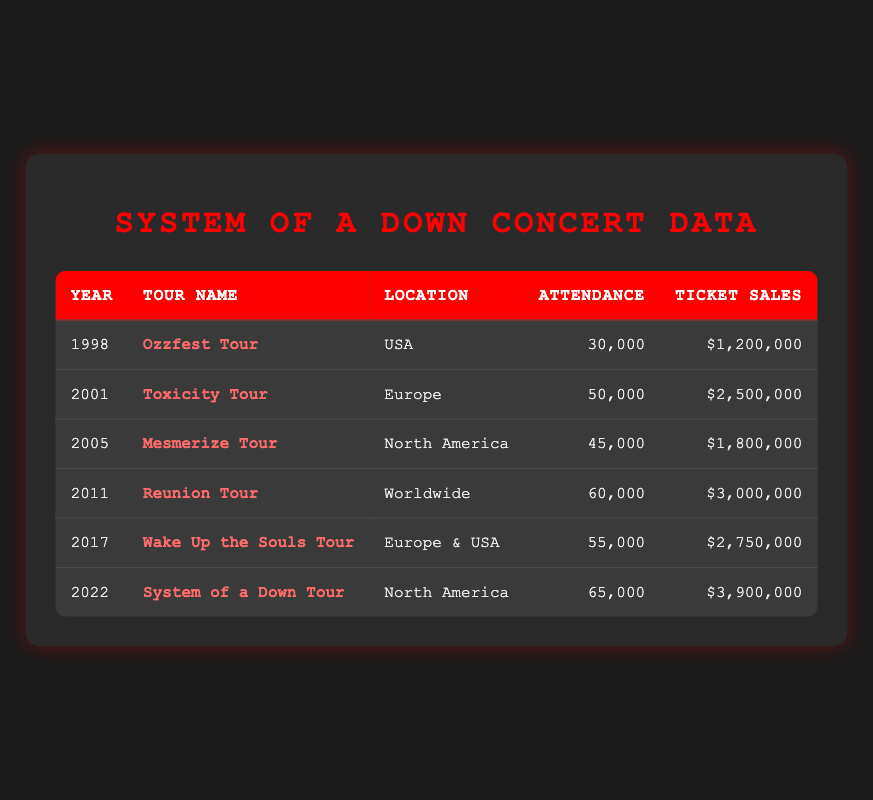What was the attendance for the Mesmerize Tour? Looking at the row for the Mesmerize Tour, the attendance listed is 45,000.
Answer: 45,000 Which tour had the highest ticket sales? The Reunion Tour had ticket sales of 3,000,000, which is higher than the sales of any other tour listed in the table.
Answer: Reunion Tour What is the total attendance for all concerts listed? To find the total attendance, add up the attendance from all tours: 30,000 + 50,000 + 45,000 + 60,000 + 55,000 + 65,000 = 305,000.
Answer: 305,000 Did the Wake Up the Souls Tour have more attendance than the Ozzfest Tour? The attendance for the Wake Up the Souls Tour is 55,000, while the Ozzfest Tour had 30,000. Therefore, Wake Up the Souls Tour had more attendance.
Answer: Yes What was the average ticket sales across all years? First, sum the ticket sales: 1,200,000 + 2,500,000 + 1,800,000 + 3,000,000 + 2,750,000 + 3,900,000 = 15,150,000. Then, divide by the number of tours (6): 15,150,000 / 6 = 2,525,000.
Answer: 2,525,000 Which tour had attendance less than 50,000? The Ozzfest Tour (30,000) and the Mesmerize Tour (45,000) both had attendance less than 50,000.
Answer: Ozzfest Tour and Mesmerize Tour How many tours took place in North America? The tours that took place in North America are the Mesmerize Tour and the System of a Down Tour. Therefore, there are 2 tours in total.
Answer: 2 Which tour had an attendance of over 60,000? The System of a Down Tour had an attendance of 65,000, which is over 60,000.
Answer: System of a Down Tour What is the difference in ticket sales between the Toxicity Tour and the System of a Down Tour? The ticket sales for the Toxicity Tour are 2,500,000, and for the System of a Down Tour, they are 3,900,000. The difference is 3,900,000 - 2,500,000 = 1,400,000.
Answer: 1,400,000 